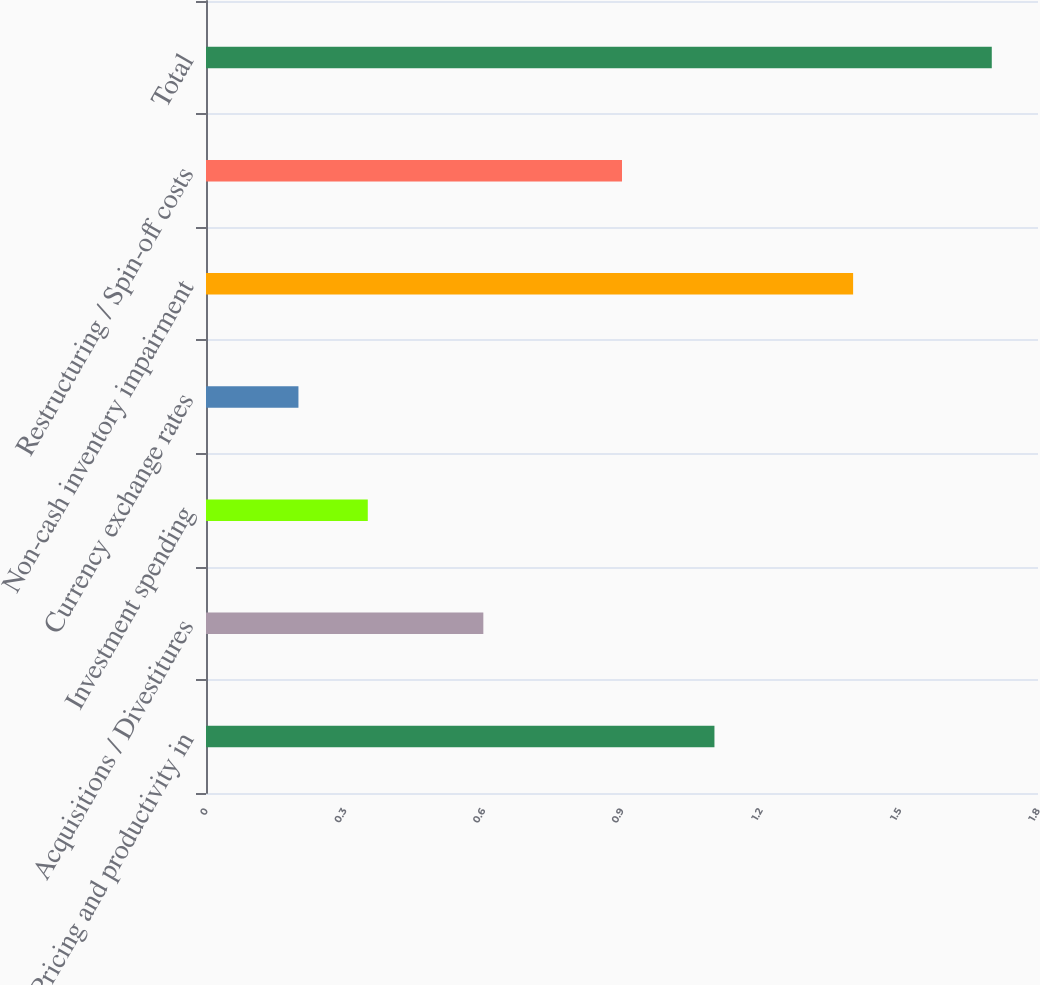Convert chart. <chart><loc_0><loc_0><loc_500><loc_500><bar_chart><fcel>Pricing and productivity in<fcel>Acquisitions / Divestitures<fcel>Investment spending<fcel>Currency exchange rates<fcel>Non-cash inventory impairment<fcel>Restructuring / Spin-off costs<fcel>Total<nl><fcel>1.1<fcel>0.6<fcel>0.35<fcel>0.2<fcel>1.4<fcel>0.9<fcel>1.7<nl></chart> 